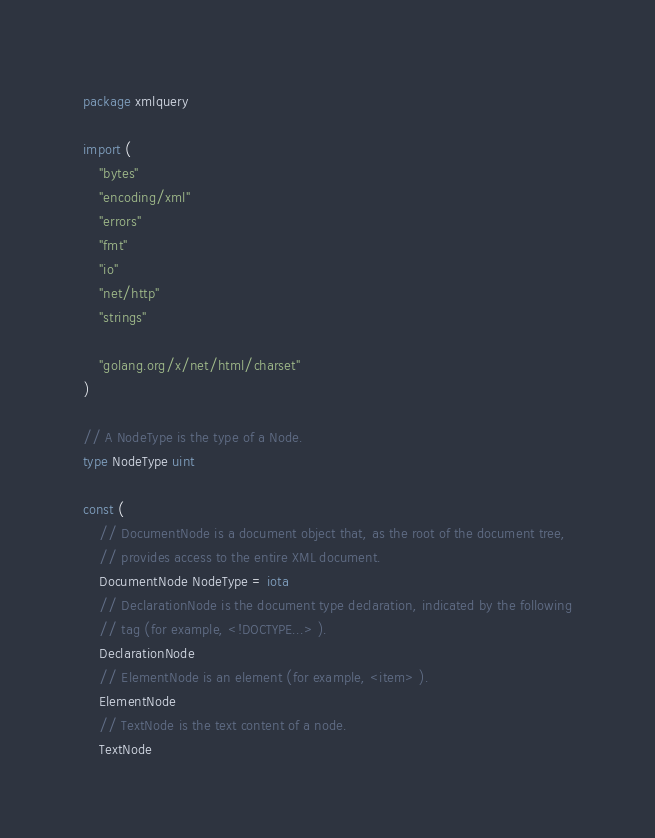<code> <loc_0><loc_0><loc_500><loc_500><_Go_>package xmlquery

import (
	"bytes"
	"encoding/xml"
	"errors"
	"fmt"
	"io"
	"net/http"
	"strings"

	"golang.org/x/net/html/charset"
)

// A NodeType is the type of a Node.
type NodeType uint

const (
	// DocumentNode is a document object that, as the root of the document tree,
	// provides access to the entire XML document.
	DocumentNode NodeType = iota
	// DeclarationNode is the document type declaration, indicated by the following
	// tag (for example, <!DOCTYPE...> ).
	DeclarationNode
	// ElementNode is an element (for example, <item> ).
	ElementNode
	// TextNode is the text content of a node.
	TextNode</code> 